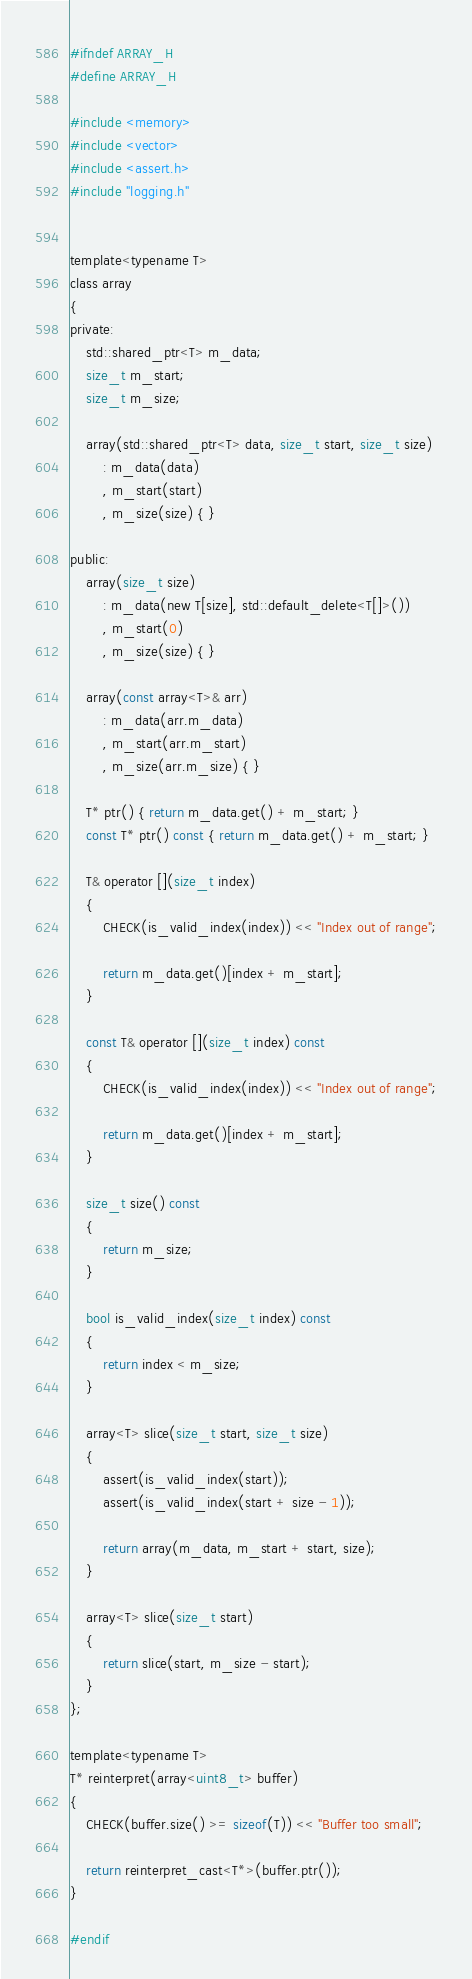Convert code to text. <code><loc_0><loc_0><loc_500><loc_500><_C_>#ifndef ARRAY_H
#define ARRAY_H

#include <memory>
#include <vector>
#include <assert.h>
#include "logging.h"


template<typename T>
class array
{
private:
    std::shared_ptr<T> m_data;
    size_t m_start;
    size_t m_size;

    array(std::shared_ptr<T> data, size_t start, size_t size)
        : m_data(data)
        , m_start(start)
        , m_size(size) { }

public:
    array(size_t size)
        : m_data(new T[size], std::default_delete<T[]>())
        , m_start(0)
        , m_size(size) { }

    array(const array<T>& arr)
        : m_data(arr.m_data)
        , m_start(arr.m_start)
        , m_size(arr.m_size) { }

    T* ptr() { return m_data.get() + m_start; }
    const T* ptr() const { return m_data.get() + m_start; }

    T& operator [](size_t index)
    {
        CHECK(is_valid_index(index)) << "Index out of range";
         
        return m_data.get()[index + m_start];
    }

    const T& operator [](size_t index) const
    {
        CHECK(is_valid_index(index)) << "Index out of range";

        return m_data.get()[index + m_start];
    }

    size_t size() const
    {
        return m_size;
    }

    bool is_valid_index(size_t index) const
    {
        return index < m_size;
    }

    array<T> slice(size_t start, size_t size)
    {
        assert(is_valid_index(start));
        assert(is_valid_index(start + size - 1));

        return array(m_data, m_start + start, size);
    }

    array<T> slice(size_t start)
    {
        return slice(start, m_size - start);
    }
};

template<typename T>
T* reinterpret(array<uint8_t> buffer)
{
    CHECK(buffer.size() >= sizeof(T)) << "Buffer too small";
    
    return reinterpret_cast<T*>(buffer.ptr());
}

#endif
</code> 